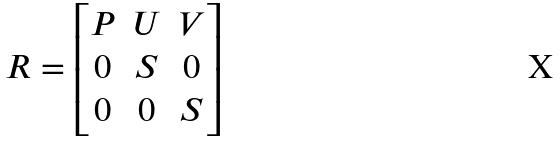Convert formula to latex. <formula><loc_0><loc_0><loc_500><loc_500>R = \begin{bmatrix} P & U & V \\ 0 & S & 0 \\ 0 & 0 & S \end{bmatrix}</formula> 